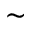<formula> <loc_0><loc_0><loc_500><loc_500>\sim</formula> 